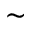<formula> <loc_0><loc_0><loc_500><loc_500>\sim</formula> 